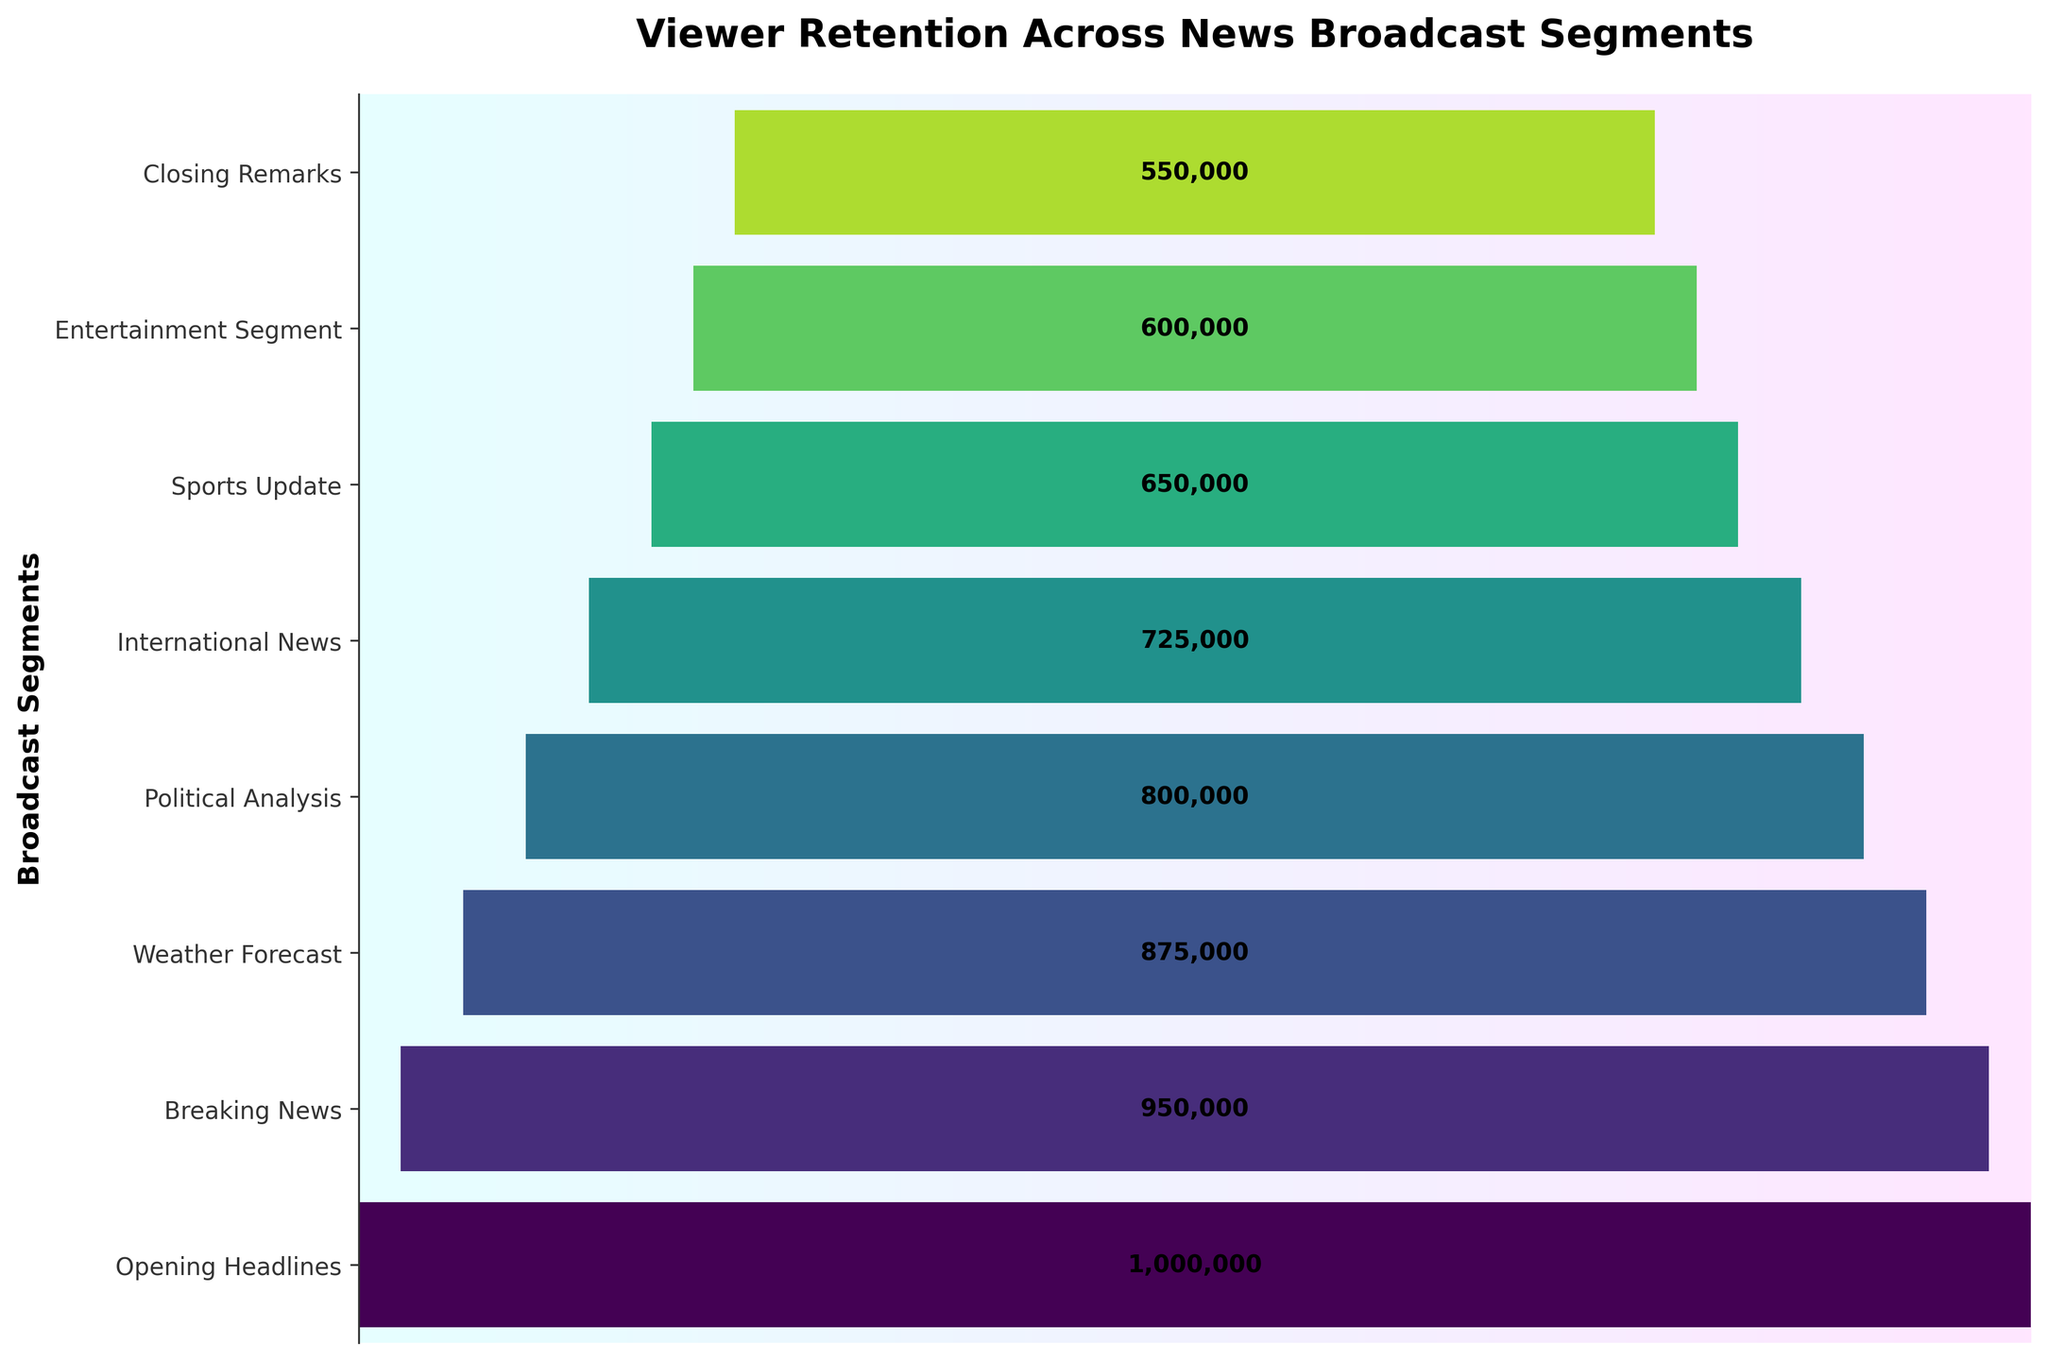Which segment has the highest number of viewers? The segment with the highest viewer count is shown at the top of the funnel chart. By looking at the topmost bar, we see "Opening Headlines."
Answer: Opening Headlines Which segment has the lowest number of viewers? The segment with the lowest viewer count is shown at the bottom of the funnel chart. By observing the bottom bar, we see "Closing Remarks."
Answer: Closing Remarks How many viewers left after the Breaking News segment? Look at the viewer count for the Breaking News segment and the next segment, which is the Weather Forecast. Subtract the Weather Forecast viewers from the Breaking News viewers: 950,000 - 875,000.
Answer: 75,000 By what percentage did viewers drop from Political Analysis to International News? First, find the difference in viewers between Political Analysis (800,000) and International News (725,000), which is 75,000. Then, divide this by the viewers of Political Analysis (800,000) and multiply by 100 to get the percentage: (75,000 / 800,000) * 100.
Answer: 9.375% How many total viewers are there across all segments? Sum up the viewer counts for all segments: 1,000,000 + 950,000 + 875,000 + 800,000 + 725,000 + 650,000 + 600,000 + 550,000.
Answer: 6,150,000 Which segment sees the largest drop in viewers? Compare the drop in viewers between each consecutive pair of segments by calculating the difference. The largest drop is between the segments with the greatest difference in viewership. 1) See differences: 50,000, 75,000, 75,000, 75,000, 75,000, 50,000, 50,000.
Answer: Breaking News to Weather Forecast / 75,000 viewers Is there a segment where the viewer count remains the same or increases? Check each segment to see if there is an increase or no change in viewers as you move down the funnel. Here, all segments show a decrease in viewers, indicating no segment has the same or increased viewership.
Answer: No What is the average number of viewers per segment? Sum the viewers from all segments and divide by the number of segments: (6,150,000 / 8).
Answer: 768,750 Which two consecutive segments have the smallest drop in viewers? Calculate the differences in viewers between each consecutive pair of segments and find the smallest difference: 1) Differences: 50,000, 75,000, 75,000, 75,000, 75,000, 50,000, 50,000. The smallest differences are 50,000. 2) Check segments: Opening Headlines to Breaking News and Sports Update to Entertainment Segment.
Answer: Opening Headlines to Breaking News & Sports Update to Entertainment Segment 